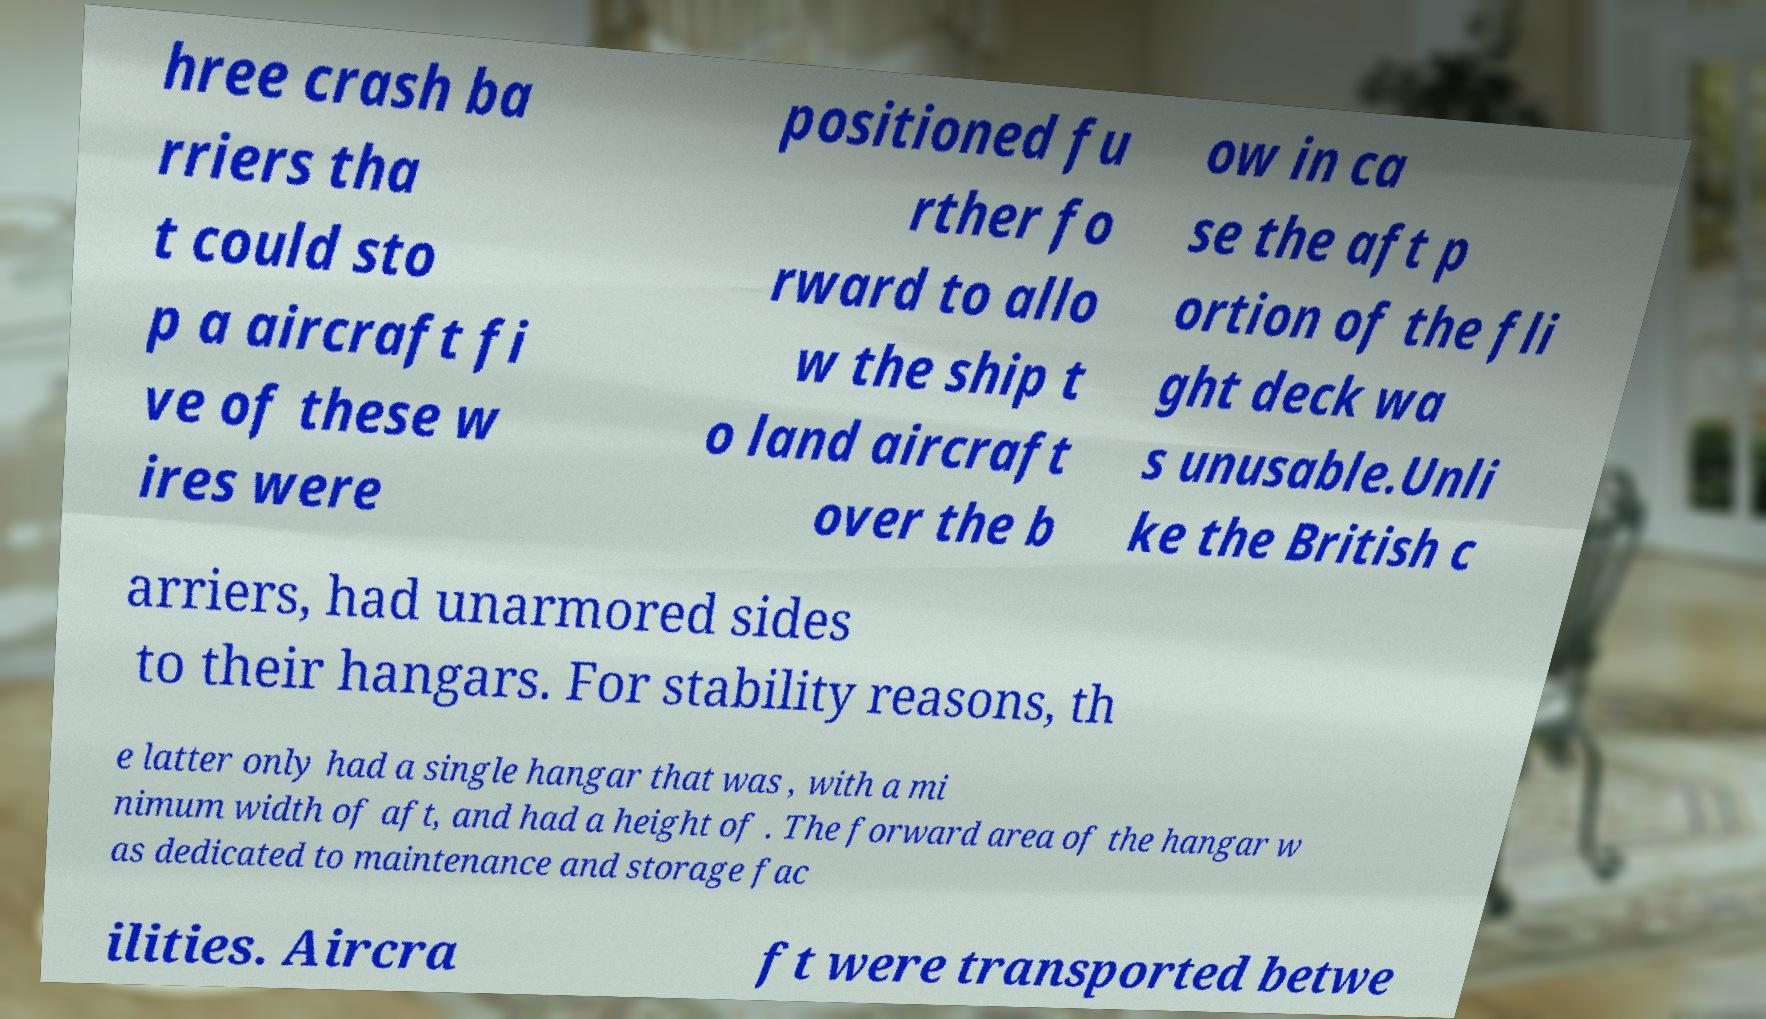Please identify and transcribe the text found in this image. hree crash ba rriers tha t could sto p a aircraft fi ve of these w ires were positioned fu rther fo rward to allo w the ship t o land aircraft over the b ow in ca se the aft p ortion of the fli ght deck wa s unusable.Unli ke the British c arriers, had unarmored sides to their hangars. For stability reasons, th e latter only had a single hangar that was , with a mi nimum width of aft, and had a height of . The forward area of the hangar w as dedicated to maintenance and storage fac ilities. Aircra ft were transported betwe 